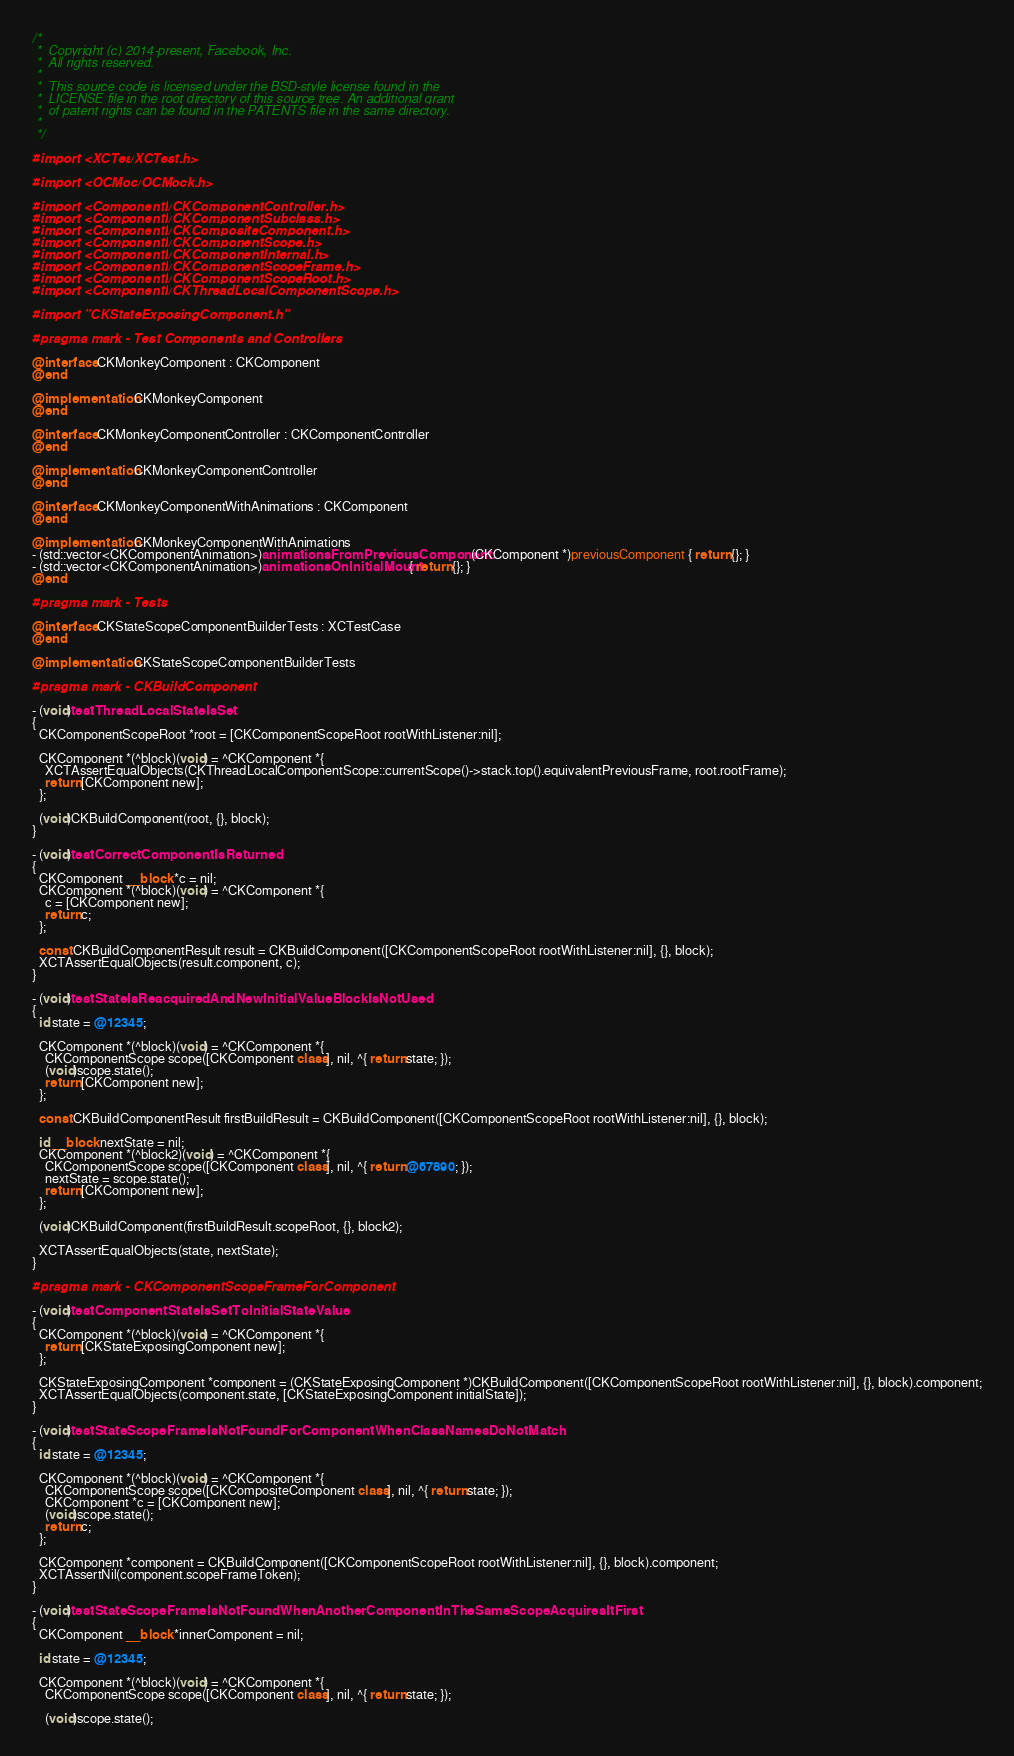Convert code to text. <code><loc_0><loc_0><loc_500><loc_500><_ObjectiveC_>/*
 *  Copyright (c) 2014-present, Facebook, Inc.
 *  All rights reserved.
 *
 *  This source code is licensed under the BSD-style license found in the
 *  LICENSE file in the root directory of this source tree. An additional grant
 *  of patent rights can be found in the PATENTS file in the same directory.
 *
 */

#import <XCTest/XCTest.h>

#import <OCMock/OCMock.h>

#import <ComponentKit/CKComponentController.h>
#import <ComponentKit/CKComponentSubclass.h>
#import <ComponentKit/CKCompositeComponent.h>
#import <ComponentKit/CKComponentScope.h>
#import <ComponentKit/CKComponentInternal.h>
#import <ComponentKit/CKComponentScopeFrame.h>
#import <ComponentKit/CKComponentScopeRoot.h>
#import <ComponentKit/CKThreadLocalComponentScope.h>

#import "CKStateExposingComponent.h"

#pragma mark - Test Components and Controllers

@interface CKMonkeyComponent : CKComponent
@end

@implementation CKMonkeyComponent
@end

@interface CKMonkeyComponentController : CKComponentController
@end

@implementation CKMonkeyComponentController
@end

@interface CKMonkeyComponentWithAnimations : CKComponent
@end

@implementation CKMonkeyComponentWithAnimations
- (std::vector<CKComponentAnimation>)animationsFromPreviousComponent:(CKComponent *)previousComponent { return {}; }
- (std::vector<CKComponentAnimation>)animationsOnInitialMount { return {}; }
@end

#pragma mark - Tests

@interface CKStateScopeComponentBuilderTests : XCTestCase
@end

@implementation CKStateScopeComponentBuilderTests

#pragma mark - CKBuildComponent

- (void)testThreadLocalStateIsSet
{
  CKComponentScopeRoot *root = [CKComponentScopeRoot rootWithListener:nil];

  CKComponent *(^block)(void) = ^CKComponent *{
    XCTAssertEqualObjects(CKThreadLocalComponentScope::currentScope()->stack.top().equivalentPreviousFrame, root.rootFrame);
    return [CKComponent new];
  };

  (void)CKBuildComponent(root, {}, block);
}

- (void)testCorrectComponentIsReturned
{
  CKComponent __block *c = nil;
  CKComponent *(^block)(void) = ^CKComponent *{
    c = [CKComponent new];
    return c;
  };

  const CKBuildComponentResult result = CKBuildComponent([CKComponentScopeRoot rootWithListener:nil], {}, block);
  XCTAssertEqualObjects(result.component, c);
}

- (void)testStateIsReacquiredAndNewInitialValueBlockIsNotUsed
{
  id state = @12345;

  CKComponent *(^block)(void) = ^CKComponent *{
    CKComponentScope scope([CKComponent class], nil, ^{ return state; });
    (void)scope.state();
    return [CKComponent new];
  };

  const CKBuildComponentResult firstBuildResult = CKBuildComponent([CKComponentScopeRoot rootWithListener:nil], {}, block);

  id __block nextState = nil;
  CKComponent *(^block2)(void) = ^CKComponent *{
    CKComponentScope scope([CKComponent class], nil, ^{ return @67890; });
    nextState = scope.state();
    return [CKComponent new];
  };

  (void)CKBuildComponent(firstBuildResult.scopeRoot, {}, block2);

  XCTAssertEqualObjects(state, nextState);
}

#pragma mark - CKComponentScopeFrameForComponent

- (void)testComponentStateIsSetToInitialStateValue
{
  CKComponent *(^block)(void) = ^CKComponent *{
    return [CKStateExposingComponent new];
  };

  CKStateExposingComponent *component = (CKStateExposingComponent *)CKBuildComponent([CKComponentScopeRoot rootWithListener:nil], {}, block).component;
  XCTAssertEqualObjects(component.state, [CKStateExposingComponent initialState]);
}

- (void)testStateScopeFrameIsNotFoundForComponentWhenClassNamesDoNotMatch
{
  id state = @12345;

  CKComponent *(^block)(void) = ^CKComponent *{
    CKComponentScope scope([CKCompositeComponent class], nil, ^{ return state; });
    CKComponent *c = [CKComponent new];
    (void)scope.state();
    return c;
  };

  CKComponent *component = CKBuildComponent([CKComponentScopeRoot rootWithListener:nil], {}, block).component;
  XCTAssertNil(component.scopeFrameToken);
}

- (void)testStateScopeFrameIsNotFoundWhenAnotherComponentInTheSameScopeAcquiresItFirst
{
  CKComponent __block *innerComponent = nil;

  id state = @12345;

  CKComponent *(^block)(void) = ^CKComponent *{
    CKComponentScope scope([CKComponent class], nil, ^{ return state; });

    (void)scope.state();</code> 